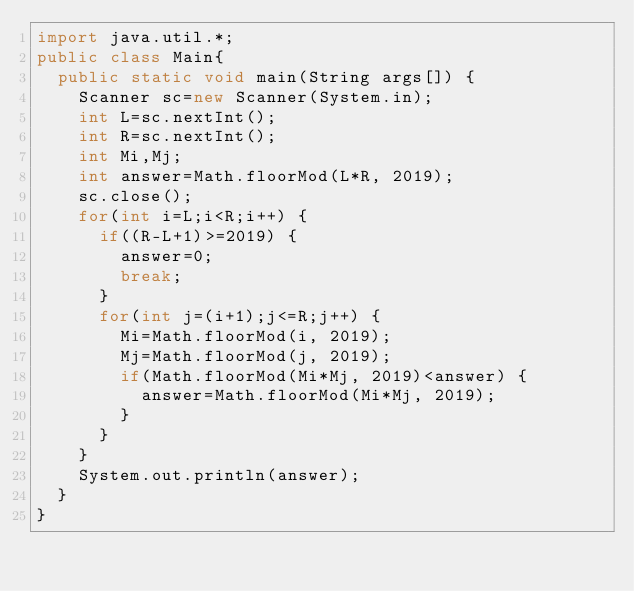<code> <loc_0><loc_0><loc_500><loc_500><_Java_>import java.util.*;
public class Main{
	public static void main(String args[]) {
		Scanner sc=new Scanner(System.in);
		int L=sc.nextInt();
		int R=sc.nextInt();
		int Mi,Mj;
		int answer=Math.floorMod(L*R, 2019);
		sc.close();
		for(int i=L;i<R;i++) {
			if((R-L+1)>=2019) {
				answer=0;
				break;
			}
			for(int j=(i+1);j<=R;j++) {
				Mi=Math.floorMod(i, 2019);
				Mj=Math.floorMod(j, 2019);
				if(Math.floorMod(Mi*Mj, 2019)<answer) {
					answer=Math.floorMod(Mi*Mj, 2019);
				}
			}
		}
		System.out.println(answer);
	}
}</code> 